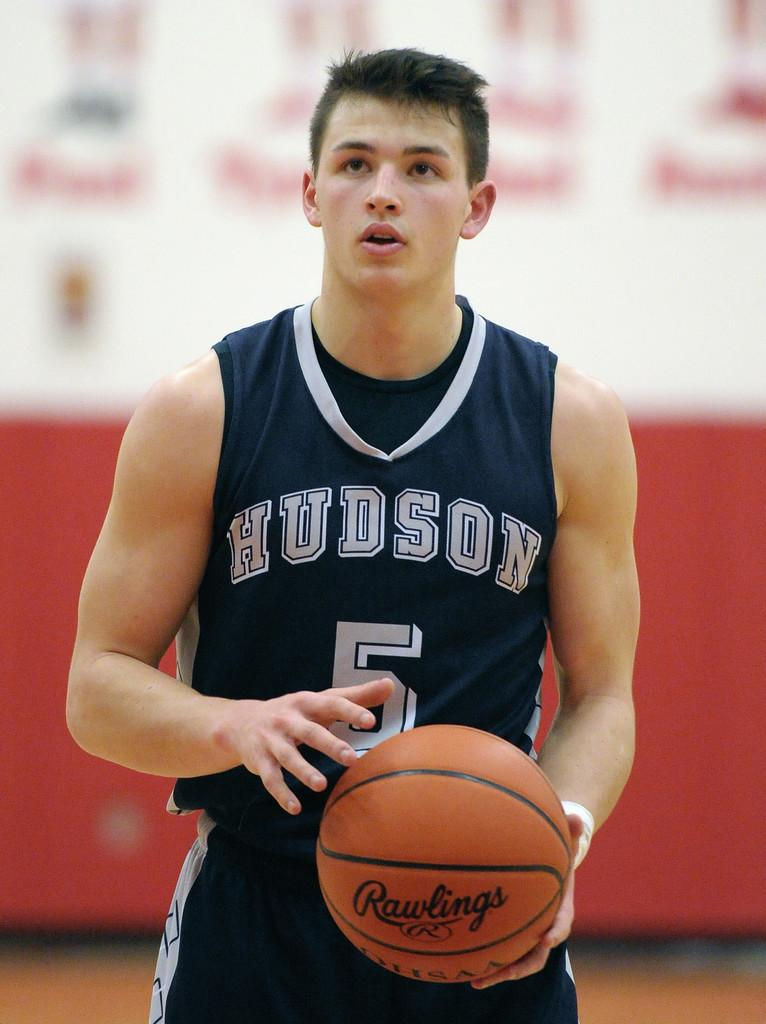Provide a one-sentence caption for the provided image. Basketball player holding a basketball with Rawlings on it. 